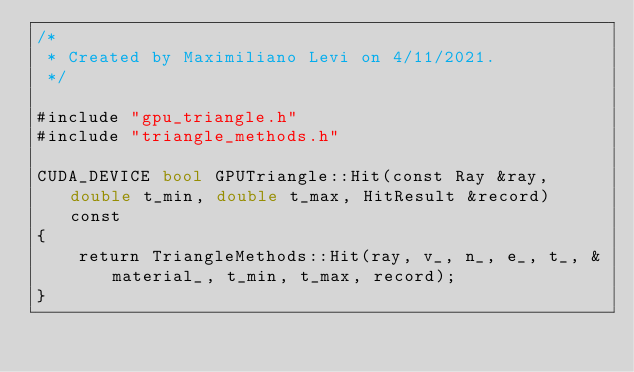<code> <loc_0><loc_0><loc_500><loc_500><_Cuda_>/*
 * Created by Maximiliano Levi on 4/11/2021.
 */

#include "gpu_triangle.h"
#include "triangle_methods.h"

CUDA_DEVICE bool GPUTriangle::Hit(const Ray &ray, double t_min, double t_max, HitResult &record) const
{
    return TriangleMethods::Hit(ray, v_, n_, e_, t_, &material_, t_min, t_max, record);
}
</code> 